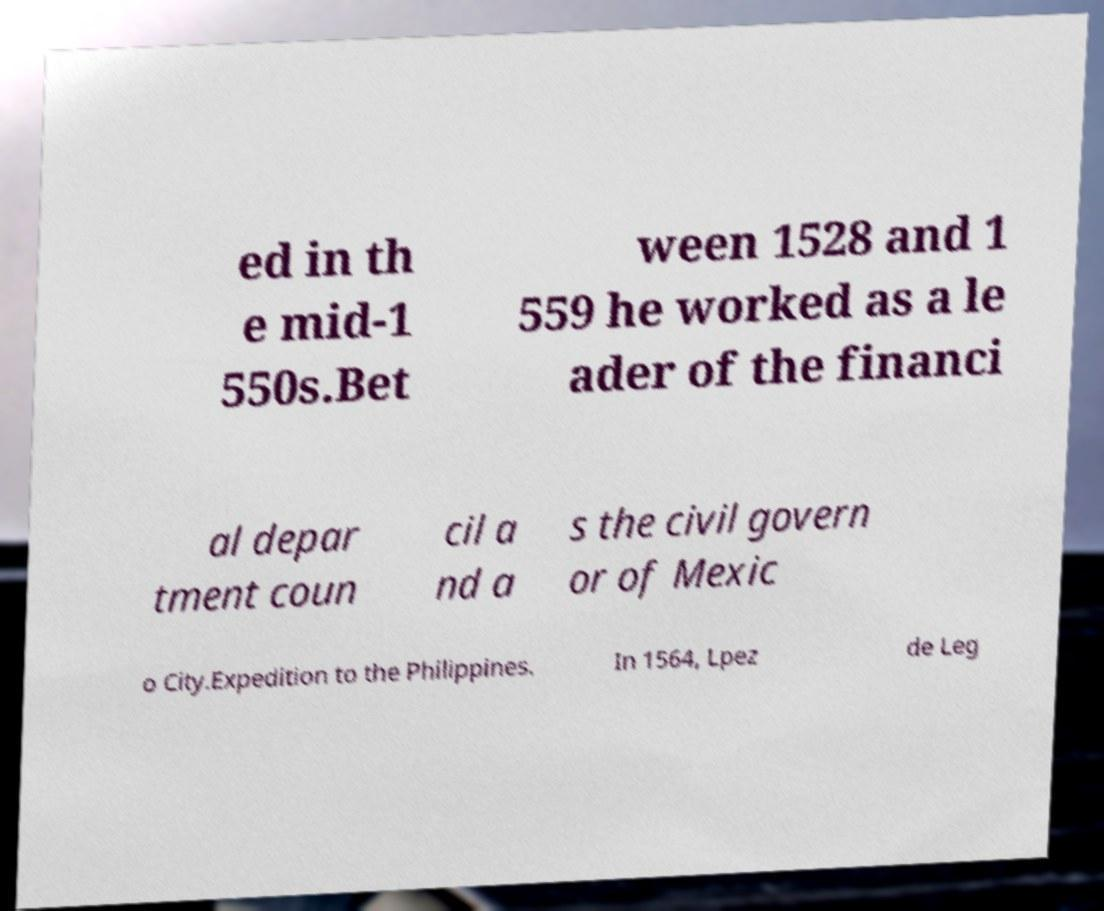Can you accurately transcribe the text from the provided image for me? ed in th e mid-1 550s.Bet ween 1528 and 1 559 he worked as a le ader of the financi al depar tment coun cil a nd a s the civil govern or of Mexic o City.Expedition to the Philippines. In 1564, Lpez de Leg 